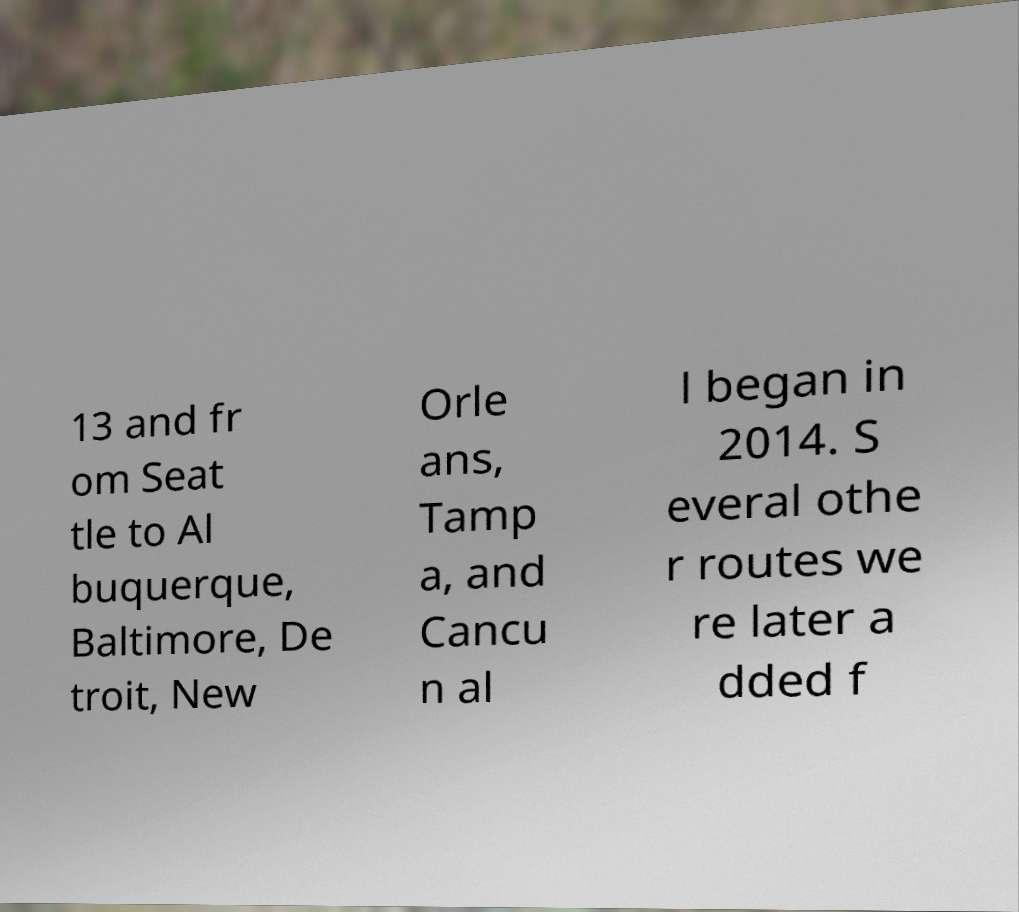Please identify and transcribe the text found in this image. 13 and fr om Seat tle to Al buquerque, Baltimore, De troit, New Orle ans, Tamp a, and Cancu n al l began in 2014. S everal othe r routes we re later a dded f 